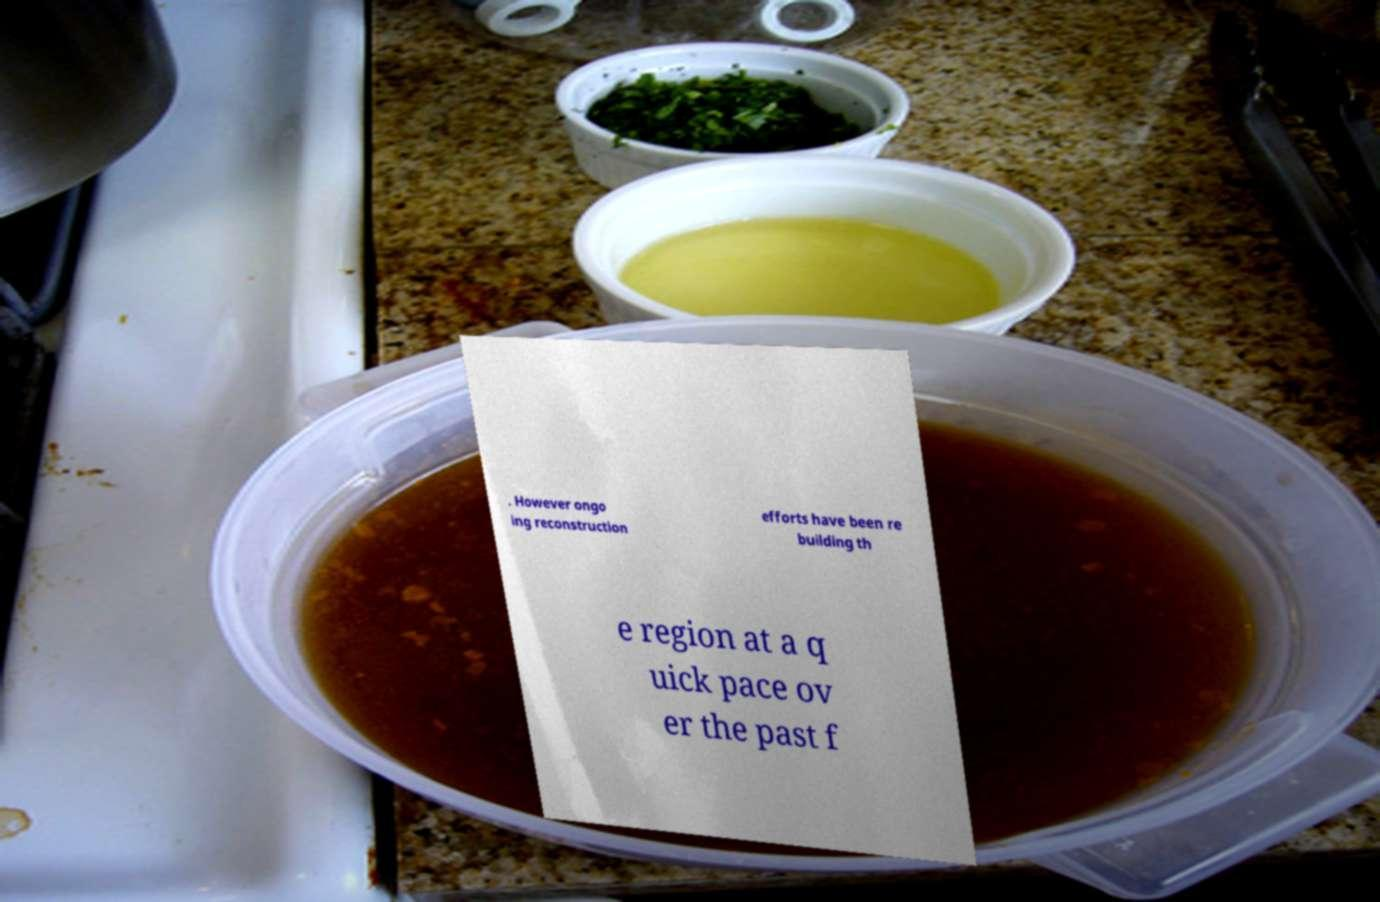For documentation purposes, I need the text within this image transcribed. Could you provide that? . However ongo ing reconstruction efforts have been re building th e region at a q uick pace ov er the past f 